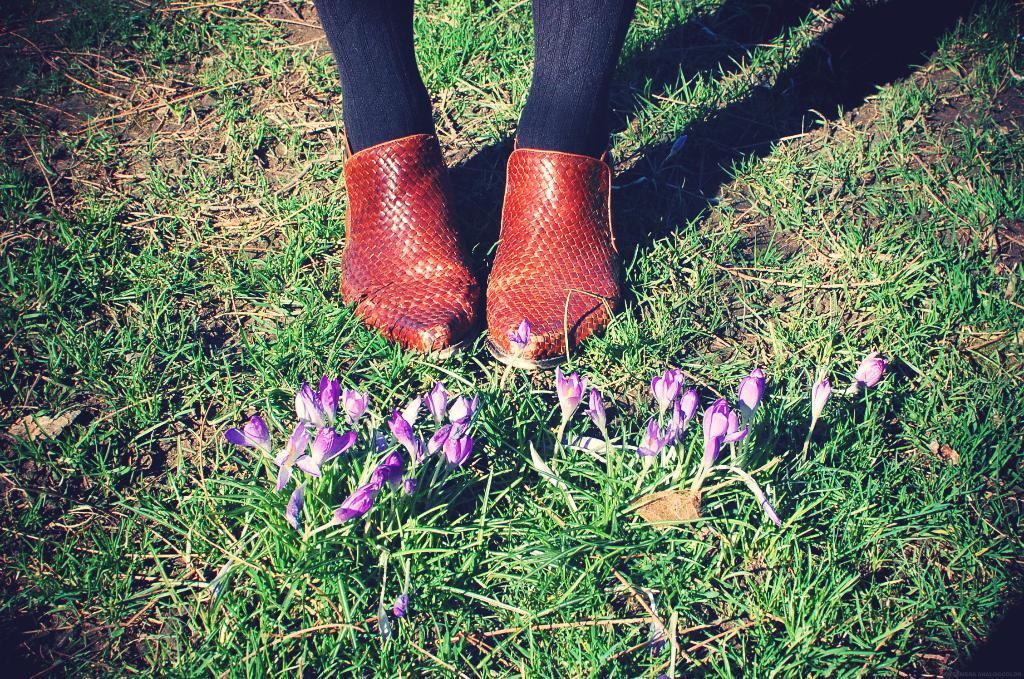What type of vegetation can be seen in the image? There is grass and flowers present in the image. What part of a person can be seen in the image? Legs of a person are visible in the image. What type of footwear is present in the image? Shoes are present in the image. What type of shade is provided by the plants in the image? There is no mention of shade or specific plants in the image, so it cannot be determined what type of shade they might provide. 